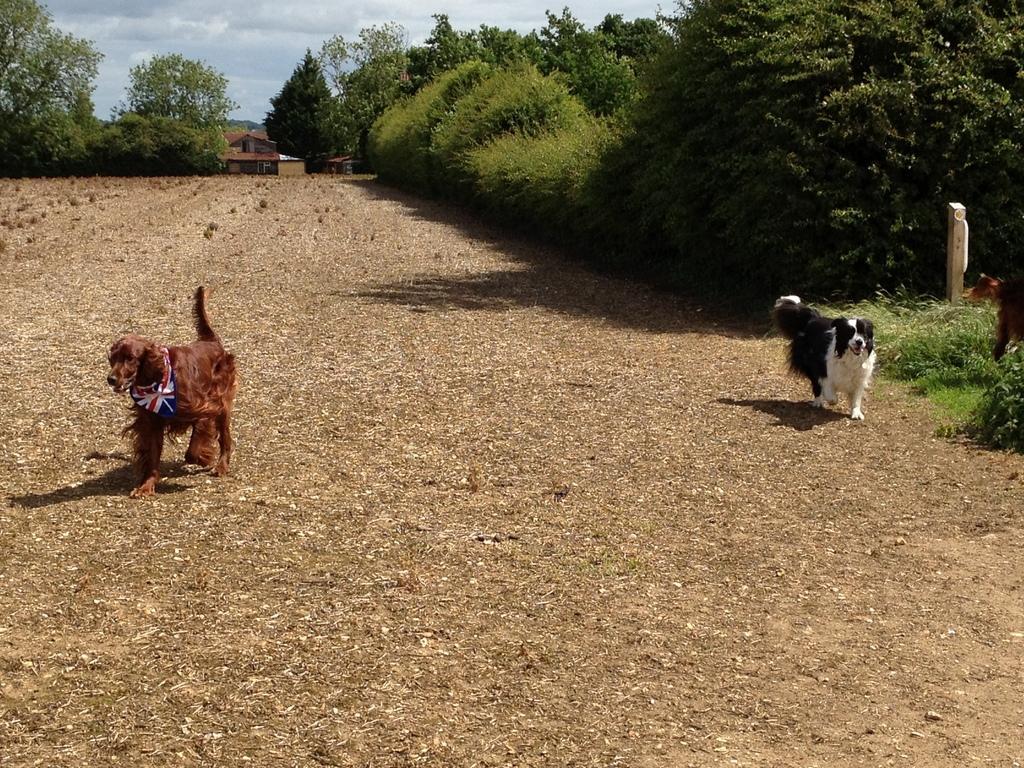Can you describe this image briefly? In this image two dogs are walking on the land. Right side there is some grass, plants and trees. There is a house, beside there are few trees. Top of image there is sky. 